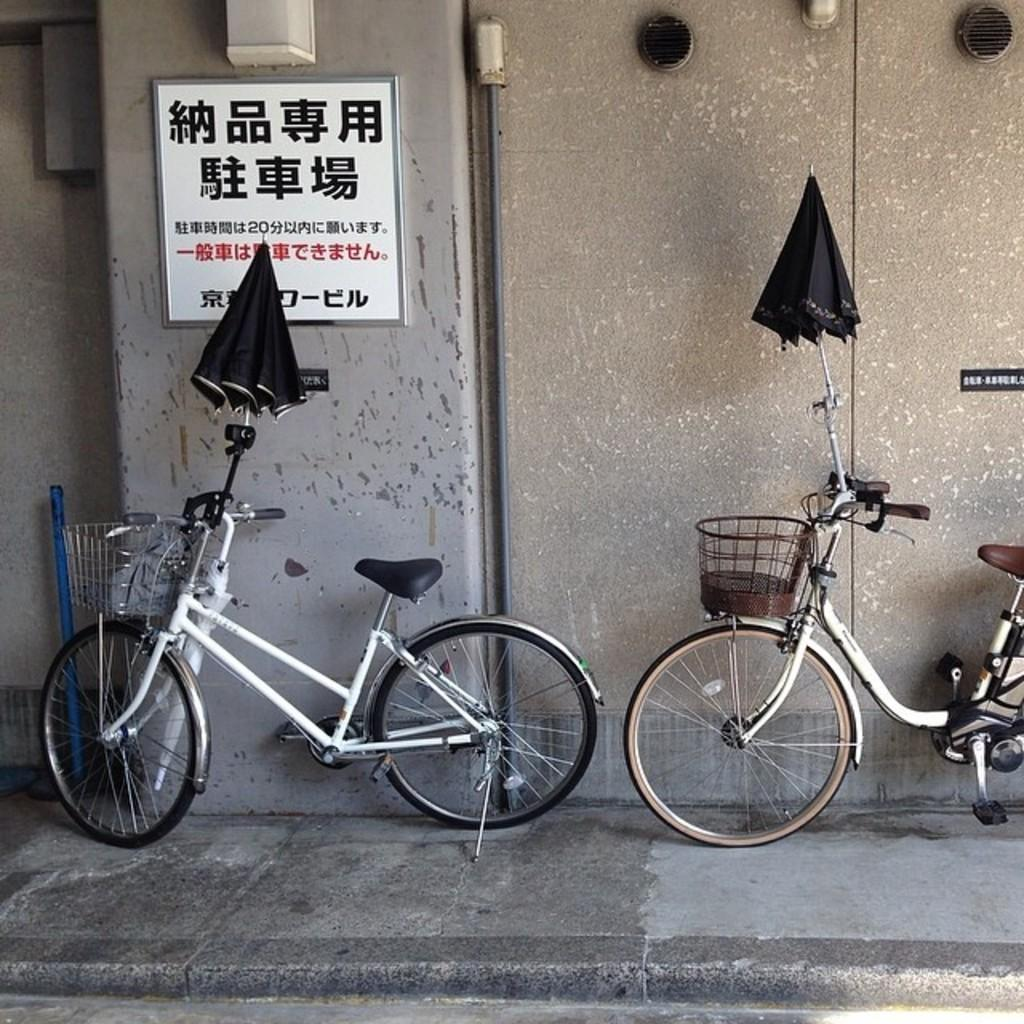How many bicycles are present in the image? There are two bicycles in the image. What other objects can be seen in the image besides bicycles? There are two umbrellas in the image. Is there any text visible in the image? Yes, there is a board on the wall with text in the image. What type of cream is being used to paint the actor's face in the image? There is no actor or face painting present in the image; it features two bicycles and two umbrellas. What type of iron is being used to press the clothes in the image? There is no iron or clothes pressing activity depicted in the image. 